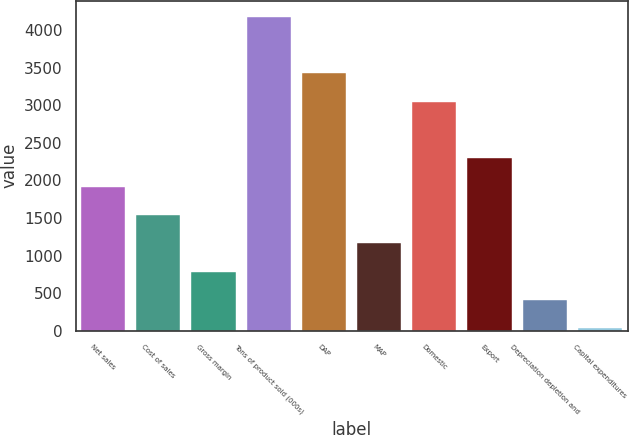Convert chart. <chart><loc_0><loc_0><loc_500><loc_500><bar_chart><fcel>Net sales<fcel>Cost of sales<fcel>Gross margin<fcel>Tons of product sold (000s)<fcel>DAP<fcel>MAP<fcel>Domestic<fcel>Export<fcel>Depreciation depletion and<fcel>Capital expenditures<nl><fcel>1918.6<fcel>1541.32<fcel>786.76<fcel>4182.28<fcel>3427.72<fcel>1164.04<fcel>3050.44<fcel>2295.88<fcel>409.48<fcel>32.2<nl></chart> 